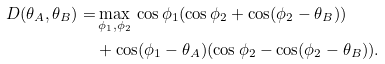Convert formula to latex. <formula><loc_0><loc_0><loc_500><loc_500>D ( \theta _ { A } , \theta _ { B } ) = & \max _ { \phi _ { 1 } , \phi _ { 2 } } \, \cos \phi _ { 1 } ( \cos \phi _ { 2 } + \cos ( \phi _ { 2 } - \theta _ { B } ) ) \\ & + \cos ( \phi _ { 1 } - \theta _ { A } ) ( \cos \phi _ { 2 } - \cos ( \phi _ { 2 } - \theta _ { B } ) ) .</formula> 